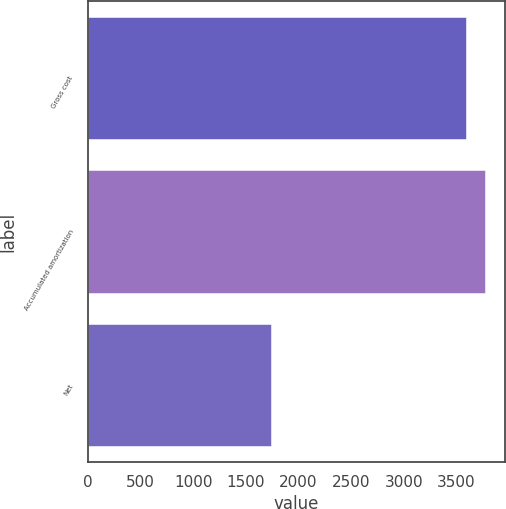<chart> <loc_0><loc_0><loc_500><loc_500><bar_chart><fcel>Gross cost<fcel>Accumulated amortization<fcel>Net<nl><fcel>3585<fcel>3769.5<fcel>1740<nl></chart> 